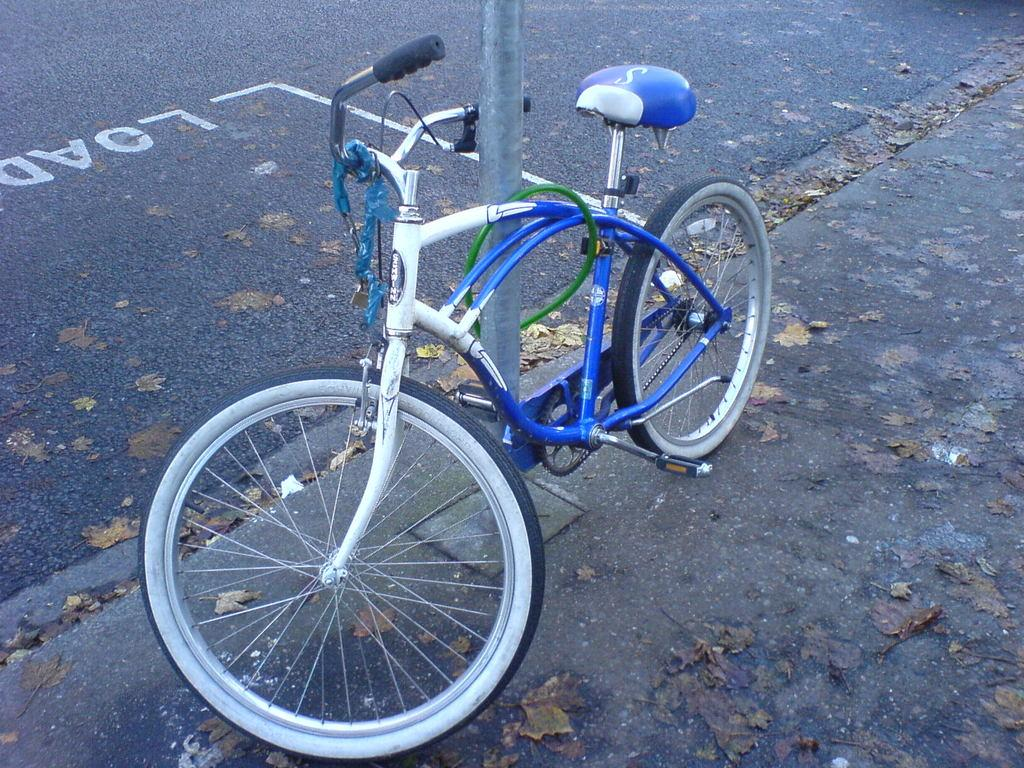What is the main object in the image? There is a bicycle in the image. What is the bicycle resting on? There is a stand in the image for the bicycle to rest on. What can be seen in the background of the image? There is a road in the image. Is there any text visible in the image? Yes, there is some text visible on the road. Can you see any fairies lifting the bicycle in the image? No, there are no fairies or any lifting action involving the bicycle in the image. 